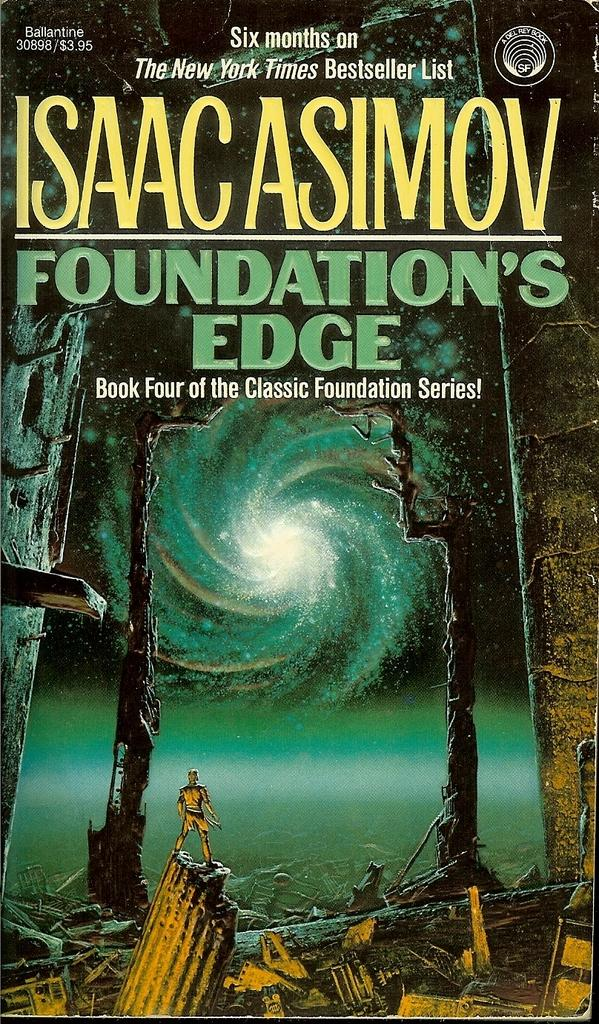<image>
Write a terse but informative summary of the picture. Foundation's Edge was on the New York Times Bestseller List for six months. 